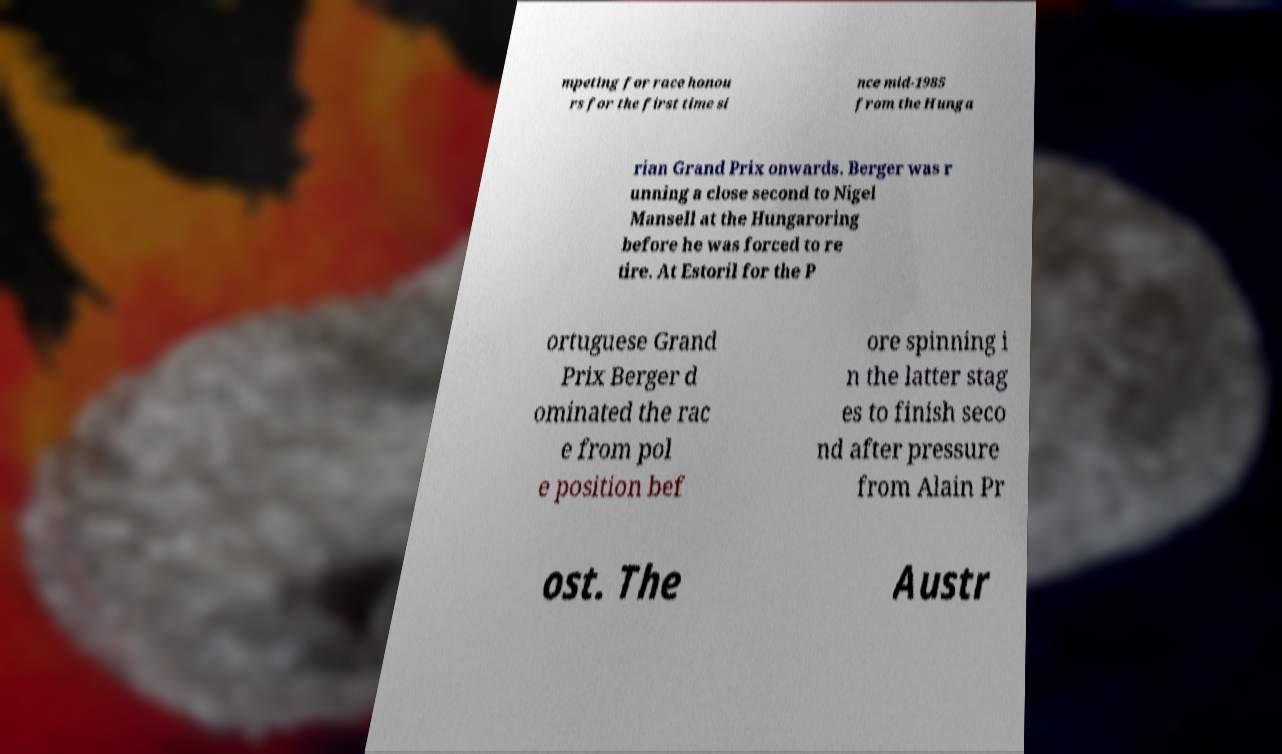Can you accurately transcribe the text from the provided image for me? mpeting for race honou rs for the first time si nce mid-1985 from the Hunga rian Grand Prix onwards. Berger was r unning a close second to Nigel Mansell at the Hungaroring before he was forced to re tire. At Estoril for the P ortuguese Grand Prix Berger d ominated the rac e from pol e position bef ore spinning i n the latter stag es to finish seco nd after pressure from Alain Pr ost. The Austr 